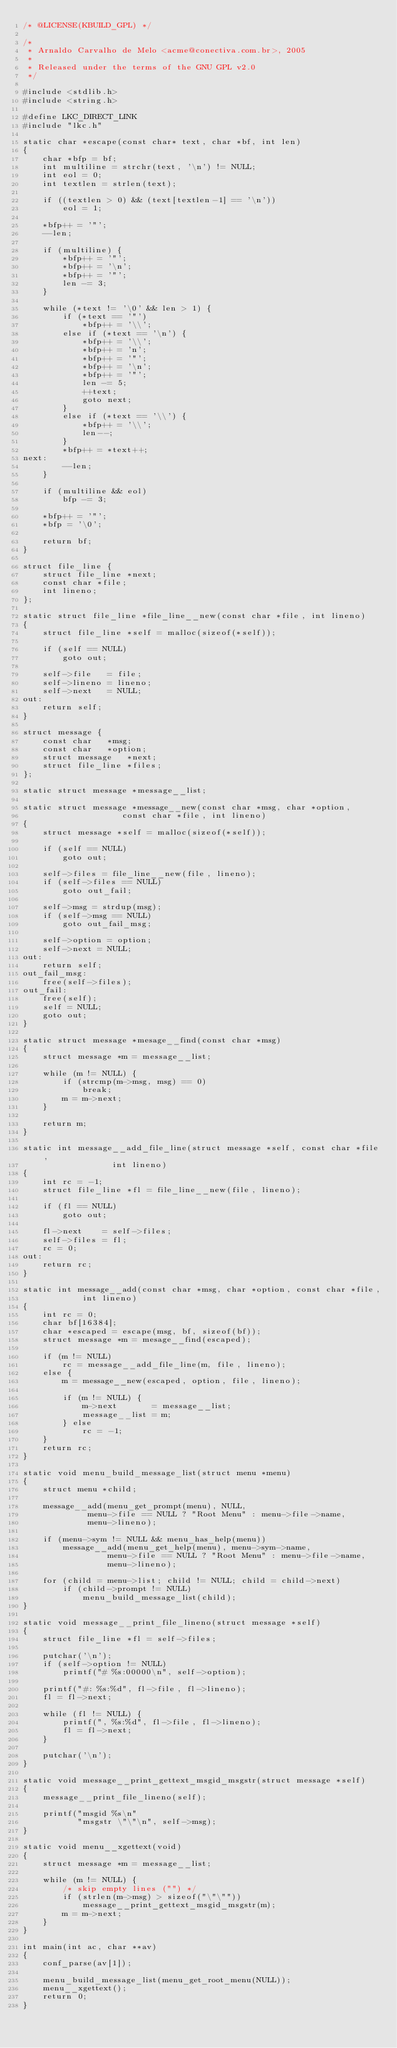<code> <loc_0><loc_0><loc_500><loc_500><_C_>/* @LICENSE(KBUILD_GPL) */

/*
 * Arnaldo Carvalho de Melo <acme@conectiva.com.br>, 2005
 *
 * Released under the terms of the GNU GPL v2.0
 */

#include <stdlib.h>
#include <string.h>

#define LKC_DIRECT_LINK
#include "lkc.h"

static char *escape(const char* text, char *bf, int len)
{
	char *bfp = bf;
	int multiline = strchr(text, '\n') != NULL;
	int eol = 0;
	int textlen = strlen(text);

	if ((textlen > 0) && (text[textlen-1] == '\n'))
		eol = 1;

	*bfp++ = '"';
	--len;

	if (multiline) {
		*bfp++ = '"';
		*bfp++ = '\n';
		*bfp++ = '"';
		len -= 3;
	}

	while (*text != '\0' && len > 1) {
		if (*text == '"')
			*bfp++ = '\\';
		else if (*text == '\n') {
			*bfp++ = '\\';
			*bfp++ = 'n';
			*bfp++ = '"';
			*bfp++ = '\n';
			*bfp++ = '"';
			len -= 5;
			++text;
			goto next;
		}
		else if (*text == '\\') {
			*bfp++ = '\\';
			len--;
		}
		*bfp++ = *text++;
next:
		--len;
	}

	if (multiline && eol)
		bfp -= 3;

	*bfp++ = '"';
	*bfp = '\0';

	return bf;
}

struct file_line {
	struct file_line *next;
	const char *file;
	int lineno;
};

static struct file_line *file_line__new(const char *file, int lineno)
{
	struct file_line *self = malloc(sizeof(*self));

	if (self == NULL)
		goto out;

	self->file   = file;
	self->lineno = lineno;
	self->next   = NULL;
out:
	return self;
}

struct message {
	const char	 *msg;
	const char	 *option;
	struct message	 *next;
	struct file_line *files;
};

static struct message *message__list;

static struct message *message__new(const char *msg, char *option,
				    const char *file, int lineno)
{
	struct message *self = malloc(sizeof(*self));

	if (self == NULL)
		goto out;

	self->files = file_line__new(file, lineno);
	if (self->files == NULL)
		goto out_fail;

	self->msg = strdup(msg);
	if (self->msg == NULL)
		goto out_fail_msg;

	self->option = option;
	self->next = NULL;
out:
	return self;
out_fail_msg:
	free(self->files);
out_fail:
	free(self);
	self = NULL;
	goto out;
}

static struct message *mesage__find(const char *msg)
{
	struct message *m = message__list;

	while (m != NULL) {
		if (strcmp(m->msg, msg) == 0)
			break;
		m = m->next;
	}

	return m;
}

static int message__add_file_line(struct message *self, const char *file,
				  int lineno)
{
	int rc = -1;
	struct file_line *fl = file_line__new(file, lineno);

	if (fl == NULL)
		goto out;

	fl->next    = self->files;
	self->files = fl;
	rc = 0;
out:
	return rc;
}

static int message__add(const char *msg, char *option, const char *file,
			int lineno)
{
	int rc = 0;
	char bf[16384];
	char *escaped = escape(msg, bf, sizeof(bf));
	struct message *m = mesage__find(escaped);

	if (m != NULL)
		rc = message__add_file_line(m, file, lineno);
	else {
		m = message__new(escaped, option, file, lineno);

		if (m != NULL) {
			m->next	      = message__list;
			message__list = m;
		} else
			rc = -1;
	}
	return rc;
}

static void menu_build_message_list(struct menu *menu)
{
	struct menu *child;

	message__add(menu_get_prompt(menu), NULL,
		     menu->file == NULL ? "Root Menu" : menu->file->name,
		     menu->lineno);

	if (menu->sym != NULL && menu_has_help(menu))
		message__add(menu_get_help(menu), menu->sym->name,
			     menu->file == NULL ? "Root Menu" : menu->file->name,
			     menu->lineno);

	for (child = menu->list; child != NULL; child = child->next)
		if (child->prompt != NULL)
			menu_build_message_list(child);
}

static void message__print_file_lineno(struct message *self)
{
	struct file_line *fl = self->files;

	putchar('\n');
	if (self->option != NULL)
		printf("# %s:00000\n", self->option);

	printf("#: %s:%d", fl->file, fl->lineno);
	fl = fl->next;

	while (fl != NULL) {
		printf(", %s:%d", fl->file, fl->lineno);
		fl = fl->next;
	}

	putchar('\n');
}

static void message__print_gettext_msgid_msgstr(struct message *self)
{
	message__print_file_lineno(self);

	printf("msgid %s\n"
	       "msgstr \"\"\n", self->msg);
}

static void menu__xgettext(void)
{
	struct message *m = message__list;

	while (m != NULL) {
		/* skip empty lines ("") */
		if (strlen(m->msg) > sizeof("\"\""))
			message__print_gettext_msgid_msgstr(m);
		m = m->next;
	}
}

int main(int ac, char **av)
{
	conf_parse(av[1]);

	menu_build_message_list(menu_get_root_menu(NULL));
	menu__xgettext();
	return 0;
}
</code> 